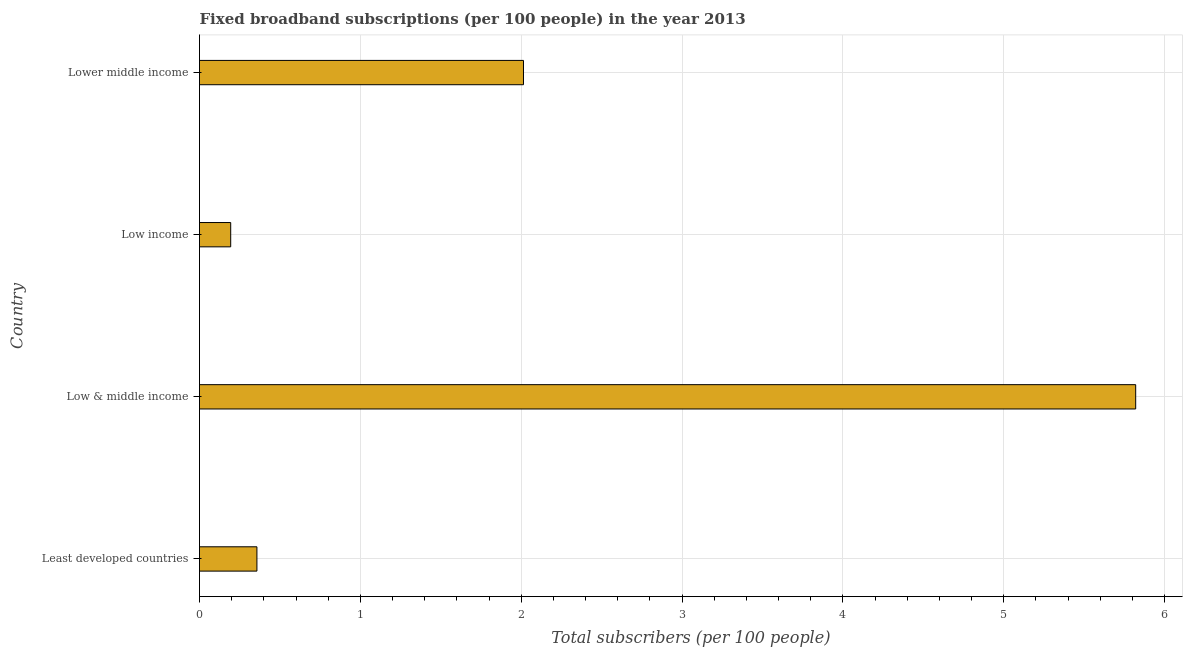Does the graph contain grids?
Provide a succinct answer. Yes. What is the title of the graph?
Your answer should be compact. Fixed broadband subscriptions (per 100 people) in the year 2013. What is the label or title of the X-axis?
Offer a terse response. Total subscribers (per 100 people). What is the total number of fixed broadband subscriptions in Least developed countries?
Offer a very short reply. 0.36. Across all countries, what is the maximum total number of fixed broadband subscriptions?
Ensure brevity in your answer.  5.82. Across all countries, what is the minimum total number of fixed broadband subscriptions?
Your answer should be compact. 0.19. What is the sum of the total number of fixed broadband subscriptions?
Provide a short and direct response. 8.39. What is the difference between the total number of fixed broadband subscriptions in Low & middle income and Lower middle income?
Your answer should be very brief. 3.81. What is the average total number of fixed broadband subscriptions per country?
Ensure brevity in your answer.  2.1. What is the median total number of fixed broadband subscriptions?
Your answer should be very brief. 1.19. In how many countries, is the total number of fixed broadband subscriptions greater than 5.6 ?
Your answer should be very brief. 1. What is the ratio of the total number of fixed broadband subscriptions in Least developed countries to that in Lower middle income?
Offer a very short reply. 0.18. Is the difference between the total number of fixed broadband subscriptions in Least developed countries and Low income greater than the difference between any two countries?
Offer a very short reply. No. What is the difference between the highest and the second highest total number of fixed broadband subscriptions?
Ensure brevity in your answer.  3.81. Is the sum of the total number of fixed broadband subscriptions in Least developed countries and Low & middle income greater than the maximum total number of fixed broadband subscriptions across all countries?
Your answer should be compact. Yes. What is the difference between the highest and the lowest total number of fixed broadband subscriptions?
Give a very brief answer. 5.63. Are all the bars in the graph horizontal?
Offer a very short reply. Yes. How many countries are there in the graph?
Give a very brief answer. 4. Are the values on the major ticks of X-axis written in scientific E-notation?
Keep it short and to the point. No. What is the Total subscribers (per 100 people) in Least developed countries?
Your answer should be compact. 0.36. What is the Total subscribers (per 100 people) of Low & middle income?
Your answer should be compact. 5.82. What is the Total subscribers (per 100 people) in Low income?
Keep it short and to the point. 0.19. What is the Total subscribers (per 100 people) in Lower middle income?
Offer a very short reply. 2.01. What is the difference between the Total subscribers (per 100 people) in Least developed countries and Low & middle income?
Keep it short and to the point. -5.46. What is the difference between the Total subscribers (per 100 people) in Least developed countries and Low income?
Provide a succinct answer. 0.16. What is the difference between the Total subscribers (per 100 people) in Least developed countries and Lower middle income?
Provide a short and direct response. -1.66. What is the difference between the Total subscribers (per 100 people) in Low & middle income and Low income?
Your answer should be compact. 5.63. What is the difference between the Total subscribers (per 100 people) in Low & middle income and Lower middle income?
Offer a very short reply. 3.81. What is the difference between the Total subscribers (per 100 people) in Low income and Lower middle income?
Offer a terse response. -1.82. What is the ratio of the Total subscribers (per 100 people) in Least developed countries to that in Low & middle income?
Provide a succinct answer. 0.06. What is the ratio of the Total subscribers (per 100 people) in Least developed countries to that in Low income?
Your answer should be very brief. 1.84. What is the ratio of the Total subscribers (per 100 people) in Least developed countries to that in Lower middle income?
Provide a succinct answer. 0.18. What is the ratio of the Total subscribers (per 100 people) in Low & middle income to that in Low income?
Your answer should be compact. 30.01. What is the ratio of the Total subscribers (per 100 people) in Low & middle income to that in Lower middle income?
Provide a succinct answer. 2.89. What is the ratio of the Total subscribers (per 100 people) in Low income to that in Lower middle income?
Make the answer very short. 0.1. 